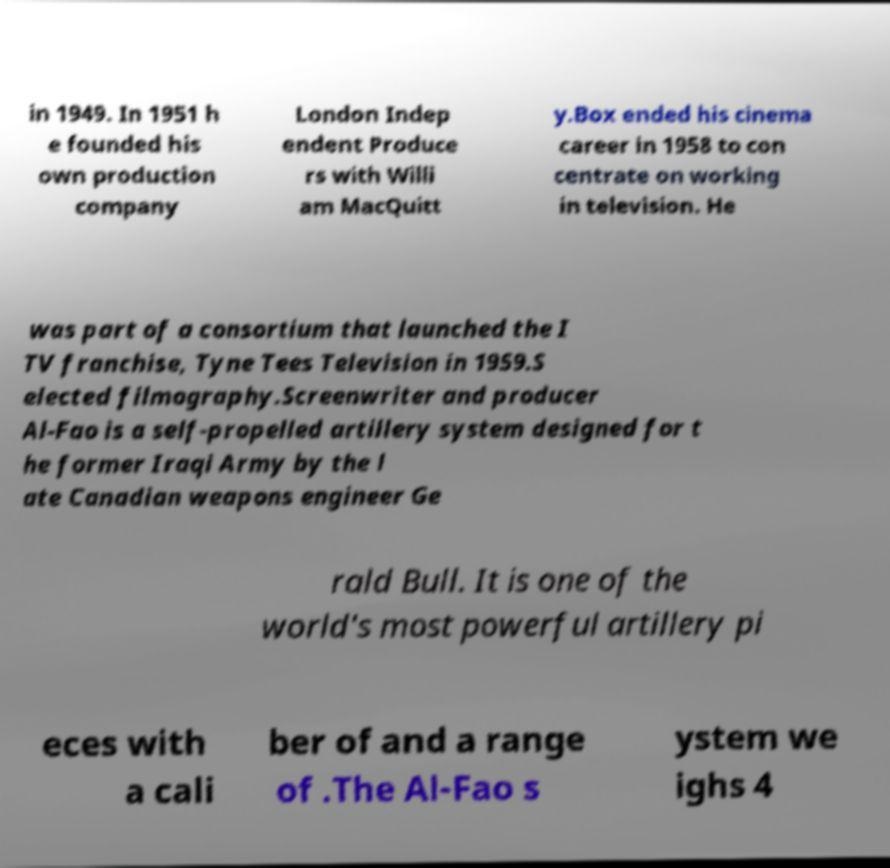There's text embedded in this image that I need extracted. Can you transcribe it verbatim? in 1949. In 1951 h e founded his own production company London Indep endent Produce rs with Willi am MacQuitt y.Box ended his cinema career in 1958 to con centrate on working in television. He was part of a consortium that launched the I TV franchise, Tyne Tees Television in 1959.S elected filmography.Screenwriter and producer Al-Fao is a self-propelled artillery system designed for t he former Iraqi Army by the l ate Canadian weapons engineer Ge rald Bull. It is one of the world's most powerful artillery pi eces with a cali ber of and a range of .The Al-Fao s ystem we ighs 4 